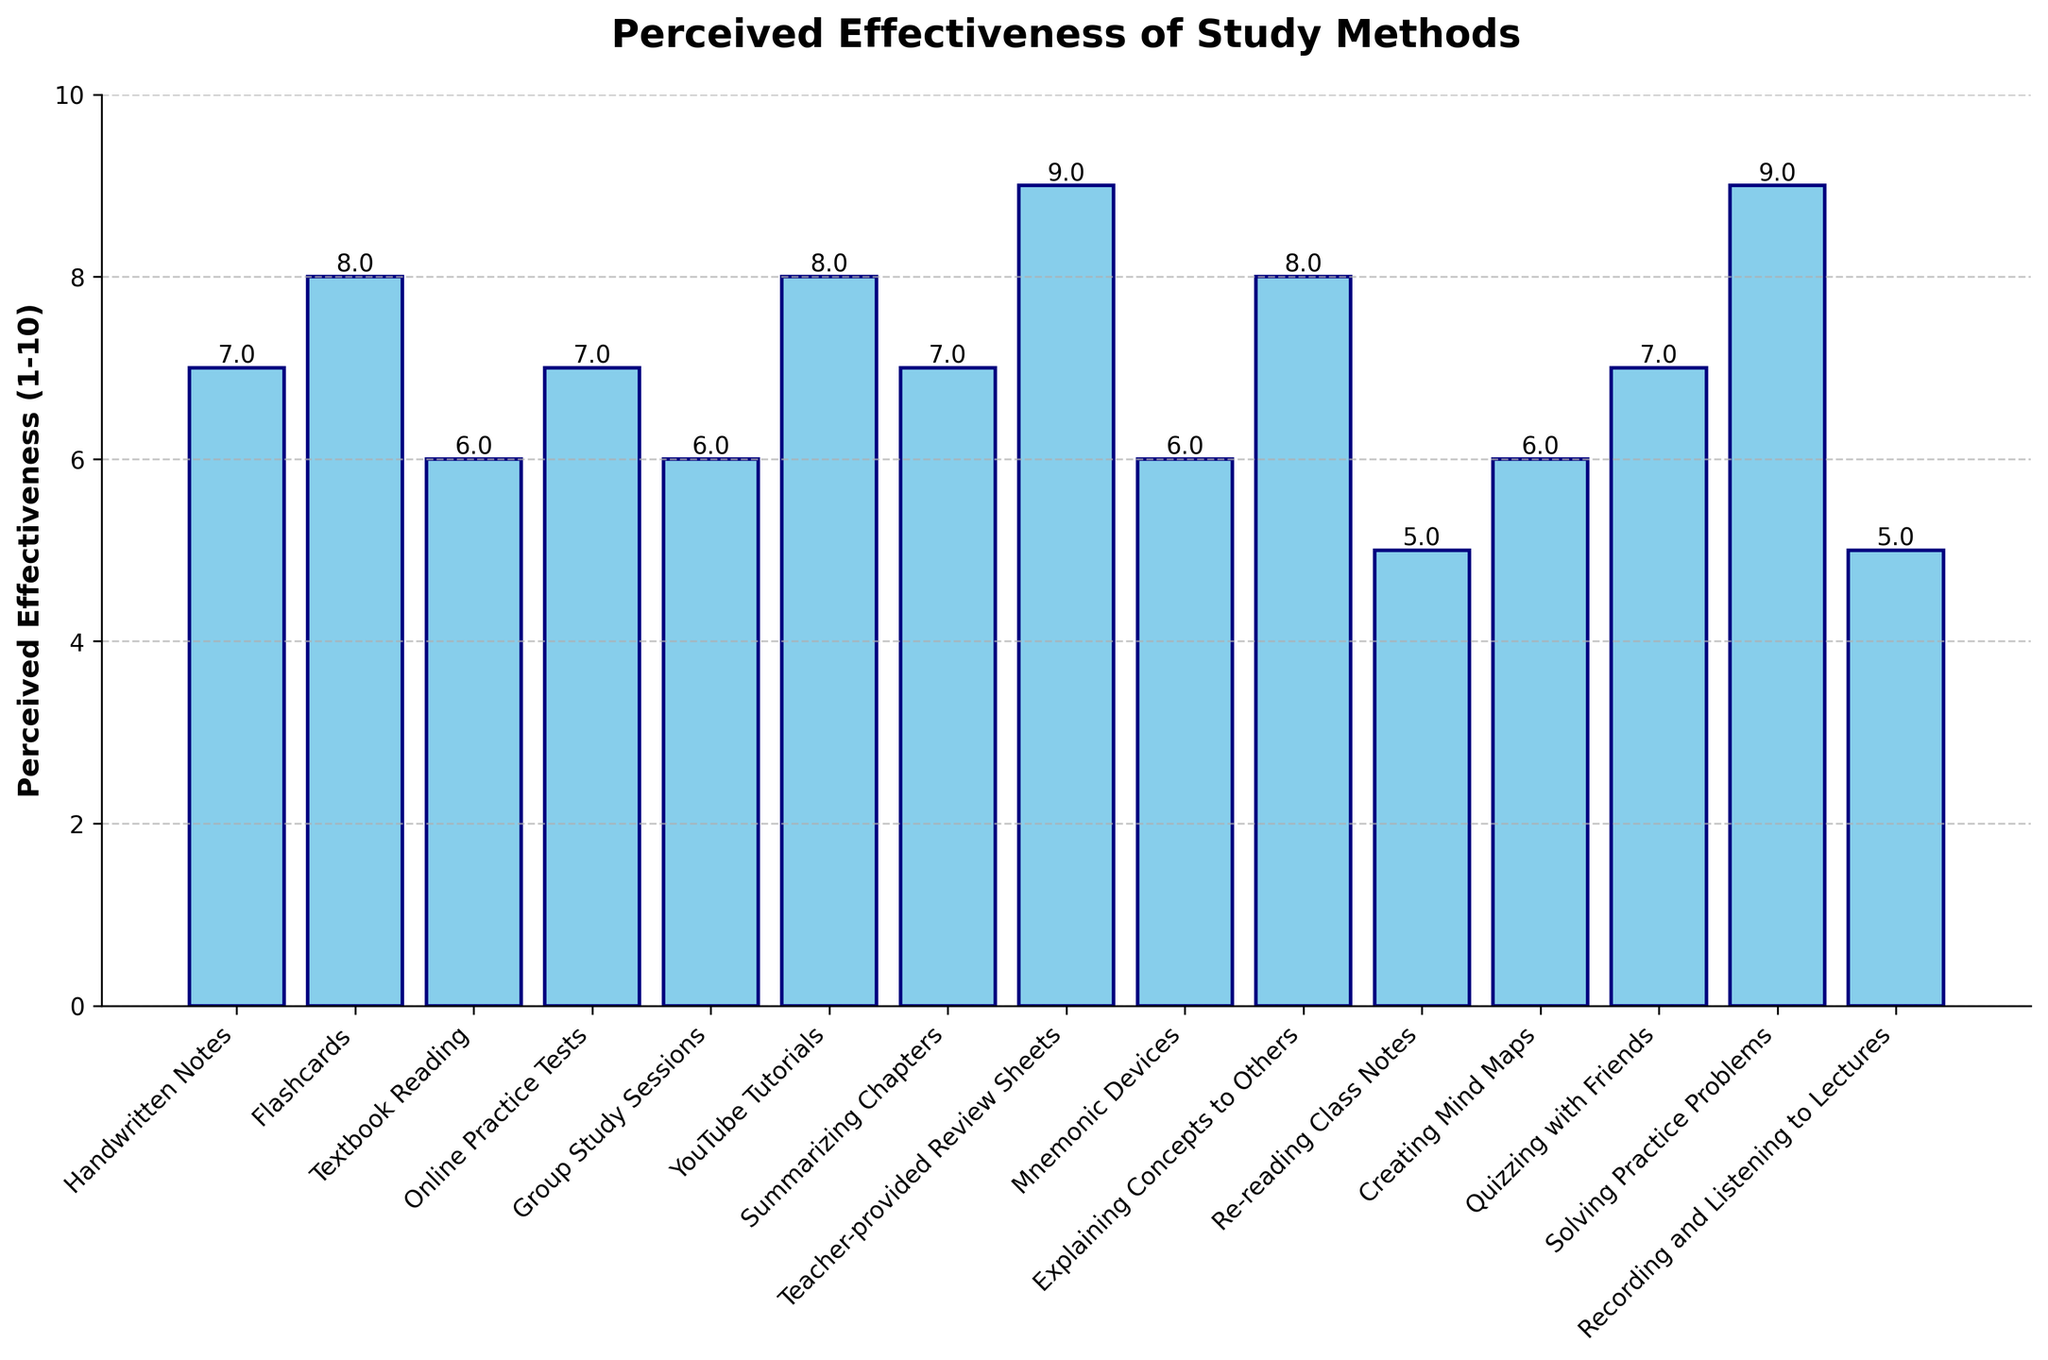Which study method has the highest perceived effectiveness? To find the highest perceived effectiveness, look at the tallest bar in the chart. The bar for "Teacher-provided Review Sheets" and "Solving Practice Problems" reaches the highest level at 9.
Answer: Teacher-provided Review Sheets and Solving Practice Problems Which study method has the lowest perceived effectiveness? Observe the shortest bars. The bars for "Re-reading Class Notes" and "Recording and Listening to Lectures" are the shortest, both rated at 5.
Answer: Re-reading Class Notes and Recording and Listening to Lectures What is the average perceived effectiveness of all study methods? Sum up the perceived effectiveness values and divide by the number of study methods. (7 + 8 + 6 + 7 + 6 + 8 + 7 + 9 + 6 + 8 + 5 + 6 + 7 + 9 + 5) / 15 = 104 / 15 = 6.93
Answer: 6.93 Which study methods are perceived as equally effective? Identify bars with the same height. "Flashcards", "YouTube Tutorials", and "Explaining Concepts to Others" all have the same perceived effectiveness of 8. "Handwritten Notes", "Online Practice Tests", "Summarizing Chapters", and "Quizzing with Friends" all have a perceived effectiveness of 7. "Textbook Reading", "Group Study Sessions", "Mnemonic Devices", and "Creating Mind Maps" each have a perceived effectiveness of 6. "Re-reading Class Notes" and "Recording and Listening to Lectures" both have a perceived effectiveness of 5.
Answer: Flashcards, YouTube Tutorials, Explaining Concepts to Others; Handwritten Notes, Online Practice Tests, Summarizing Chapters, Quizzing with Friends; Textbook Reading, Group Study Sessions, Mnemonic Devices, Creating Mind Maps; Re-reading Class Notes, Recording and Listening to Lectures What is the difference in perceived effectiveness between "Flashcards" and "Textbook Reading"? Identify the bar heights for "Flashcards" (8) and "Textbook Reading" (6), then subtract the latter from the former: 8 - 6 = 2.
Answer: 2 Which study methods have a perceived effectiveness of 9? Look for bars that reach the level of 9. "Teacher-provided Review Sheets" and "Solving Practice Problems" reach this level.
Answer: Teacher-provided Review Sheets and Solving Practice Problems Rank the study methods with perceived effectiveness of 7. Identify the bars with a height of 7 and list them. These include: "Handwritten Notes", "Online Practice Tests", "Summarizing Chapters", and "Quizzing with Friends".
Answer: Handwritten Notes, Online Practice Tests, Summarizing Chapters, Quizzing with Friends How many study methods have a perceived effectiveness of 6? Count the bars with a height of 6. These are: "Textbook Reading", "Group Study Sessions", "Mnemonic Devices", and "Creating Mind Maps".
Answer: 4 